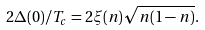Convert formula to latex. <formula><loc_0><loc_0><loc_500><loc_500>2 \Delta ( 0 ) / T _ { c } = 2 \xi ( n ) \sqrt { n ( 1 - n ) } .</formula> 